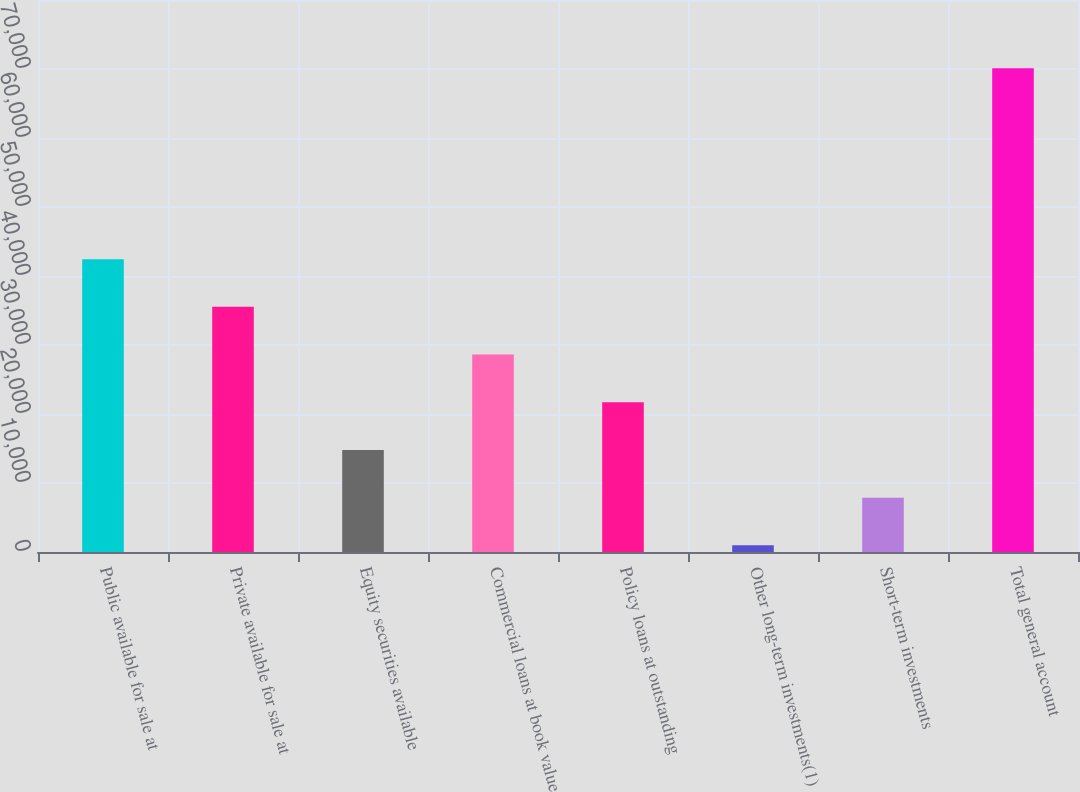Convert chart to OTSL. <chart><loc_0><loc_0><loc_500><loc_500><bar_chart><fcel>Public available for sale at<fcel>Private available for sale at<fcel>Equity securities available<fcel>Commercial loans at book value<fcel>Policy loans at outstanding<fcel>Other long-term investments(1)<fcel>Short-term investments<fcel>Total general account<nl><fcel>42442.4<fcel>35529.5<fcel>14790.8<fcel>28616.6<fcel>21703.7<fcel>965<fcel>7877.9<fcel>70094<nl></chart> 